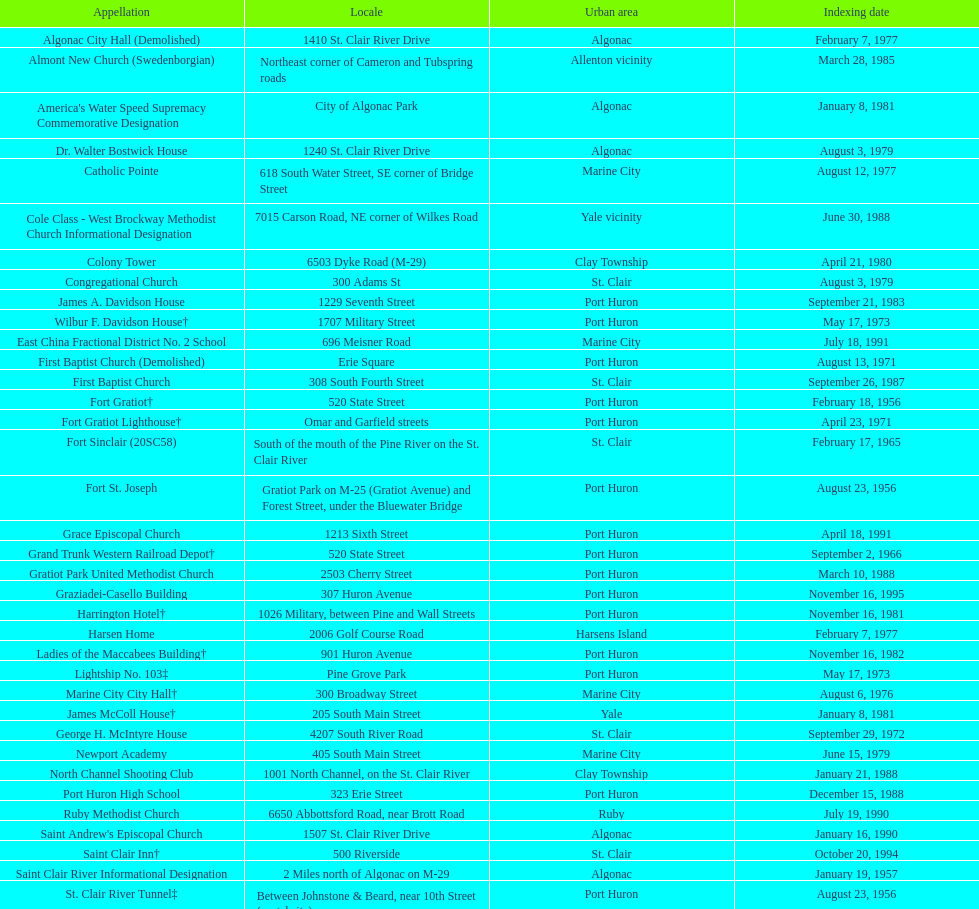What is the number of properties on the list that have been demolished? 2. 